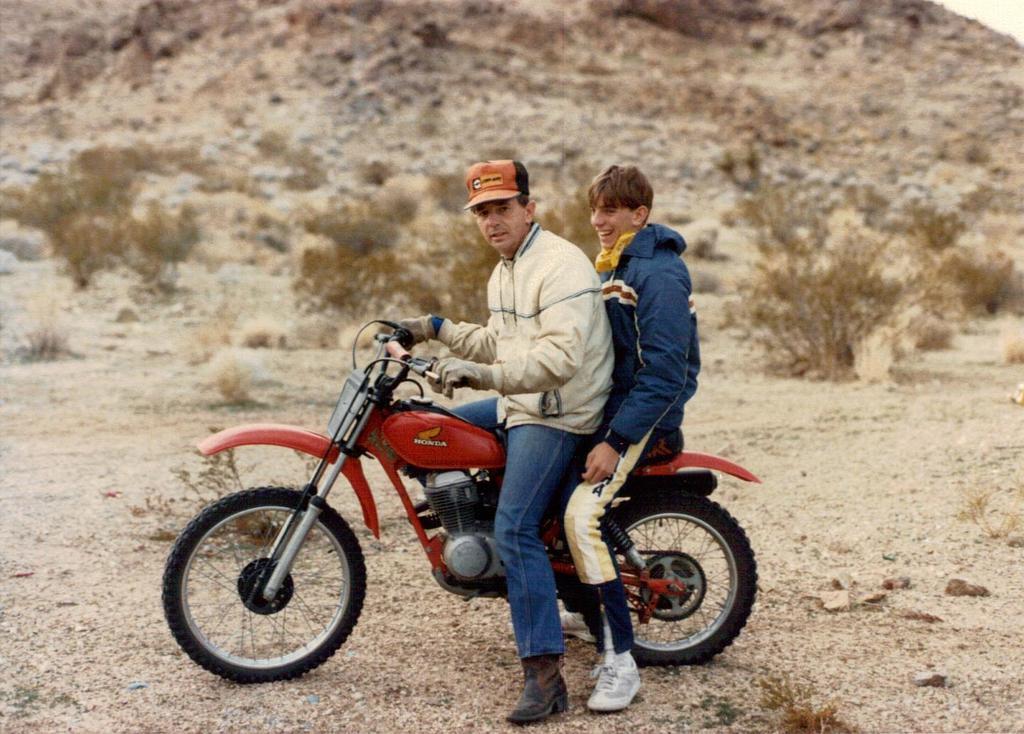Could you give a brief overview of what you see in this image? These two persons are sitting on a motorbike and wore jackets. Far there are plants. This man is smiling. This man wore cap and holding handle. 